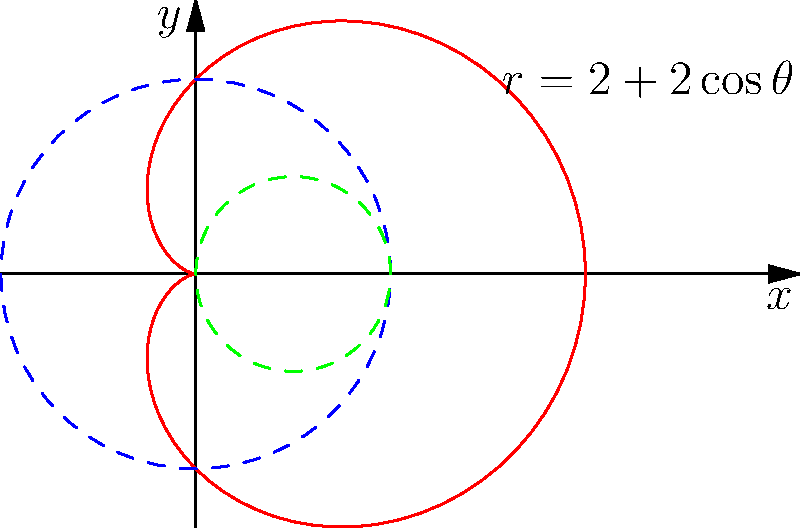As a parent eager to help your children understand advanced math concepts, you come across a polar equation $r = 2 + 2\cos\theta$. Can you convert this equation to its Cartesian form and describe the resulting shape? Let's approach this step-by-step:

1) We start with the polar equation: $r = 2 + 2\cos\theta$

2) To convert to Cartesian form, we use the relations:
   $x = r\cos\theta$ and $y = r\sin\theta$
   $r^2 = x^2 + y^2$

3) Substitute $r$ in the original equation:
   $\sqrt{x^2 + y^2} = 2 + 2\cos\theta$

4) Square both sides:
   $x^2 + y^2 = 4 + 8\cos\theta + 4\cos^2\theta$

5) Replace $\cos\theta$ with $\frac{x}{\sqrt{x^2+y^2}}$:
   $x^2 + y^2 = 4 + 8\frac{x}{\sqrt{x^2+y^2}} + 4\frac{x^2}{x^2+y^2}$

6) Simplify:
   $(x^2 + y^2)^2 = 16 + 32x + 16x^2$

7) Expand:
   $x^4 + 2x^2y^2 + y^4 = 16 + 32x + 16x^2$

8) Rearrange:
   $x^4 + 2x^2y^2 + y^4 - 16x^2 - 32x - 16 = 0$

9) Factor:
   $(x^2 + y^2 - 4x - 4)^2 = 0$

10) Take the square root:
    $x^2 + y^2 - 4x - 4 = 0$

11) Complete the square for x:
    $(x^2 - 4x) + y^2 - 4 = 0$
    $(x^2 - 4x + 4) + y^2 - 8 = 0$
    $(x - 2)^2 + y^2 = 4$

This is the equation of a circle with center (2,0) and radius 2.

The red curve in the graph represents this circle. The blue dashed circle is centered at the origin with radius 2, and the green dashed circle is centered at (1,0) with radius 1, which helps visualize how the polar equation creates this shape.
Answer: $(x - 2)^2 + y^2 = 4$; Circle with center (2,0) and radius 2 